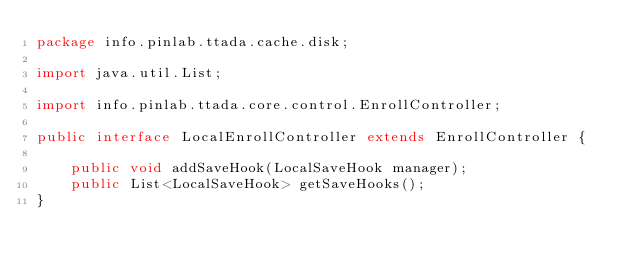<code> <loc_0><loc_0><loc_500><loc_500><_Java_>package info.pinlab.ttada.cache.disk;

import java.util.List;

import info.pinlab.ttada.core.control.EnrollController;

public interface LocalEnrollController extends EnrollController {

	public void addSaveHook(LocalSaveHook manager);
	public List<LocalSaveHook> getSaveHooks();
}
</code> 